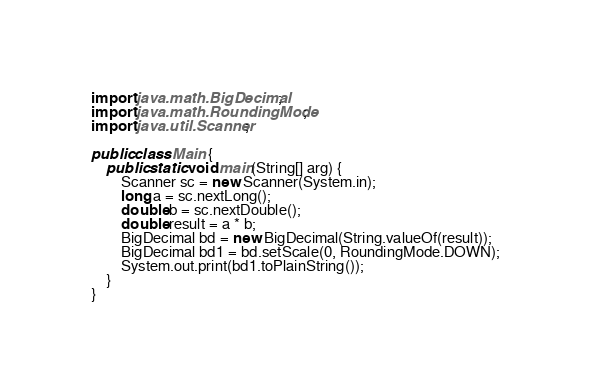<code> <loc_0><loc_0><loc_500><loc_500><_Java_>import java.math.BigDecimal;
import java.math.RoundingMode;
import java.util.Scanner;

public class Main {
    public static void main(String[] arg) {
        Scanner sc = new Scanner(System.in);
        long a = sc.nextLong();
        double b = sc.nextDouble();
        double result = a * b;
        BigDecimal bd = new BigDecimal(String.valueOf(result));
        BigDecimal bd1 = bd.setScale(0, RoundingMode.DOWN);
        System.out.print(bd1.toPlainString());
    }
}
</code> 